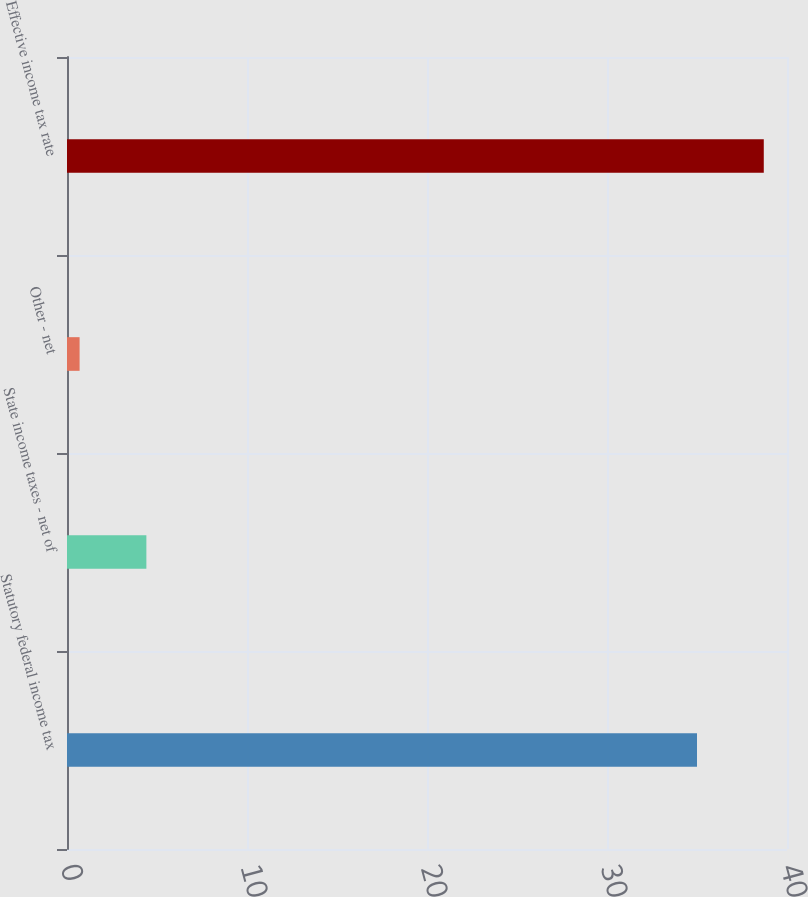Convert chart. <chart><loc_0><loc_0><loc_500><loc_500><bar_chart><fcel>Statutory federal income tax<fcel>State income taxes - net of<fcel>Other - net<fcel>Effective income tax rate<nl><fcel>35<fcel>4.41<fcel>0.7<fcel>38.71<nl></chart> 